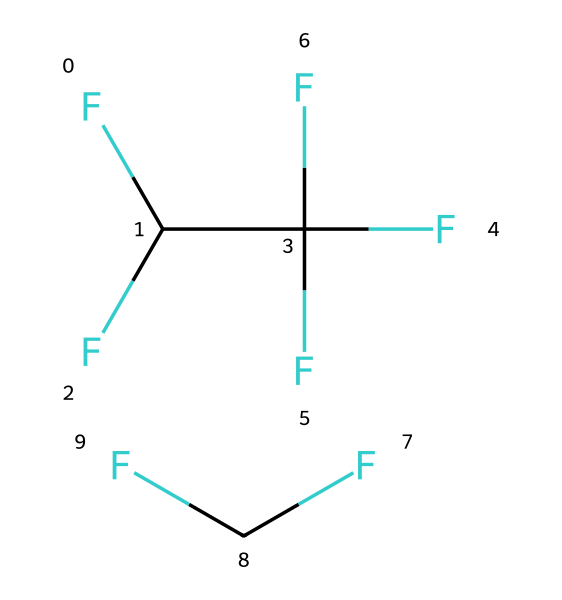How many carbon atoms are present in R-410A? By inspecting the provided SMILES representation, we can count the number of carbon (C) atoms directly. In the first part "FC(F)C(F)(F)F" there are 2 carbon atoms, and in the second part "FC(F)" there is 1 carbon atom. Therefore, adding these together gives us a total of 3 carbon atoms.
Answer: 3 What is the molecular formula of R-410A? To derive the molecular formula from the SMILES representation, we can identify the elements present. In total, there are 3 carbon atoms (C), 8 fluorine atoms (F), and 2 hydrogen atoms (H). The molecular formula combines these counts into C3H2F8.
Answer: C3H2F8 What type of chemical structure does R-410A represent? Based on its composition, R-410A is a zeotropic blend of two types of refrigerants: difluoromethane and pentafluoroethane. This indicates it has a specific structure suited for its function as a refrigerant in HVAC systems.
Answer: zeotropic blend How many fluorine atoms are in the entire R-410A molecule? By analyzing the SMILES representation, we can count the fluorine atoms. In the first portion "FC(F)(F)F" there are 4 fluorine atoms, and in the second part "FC(F)" there are 2 fluorine atoms. Thus, the total is 4 + 2 = 6 fluorine atoms.
Answer: 6 What are the primary functional groups present in R-410A? In the structure of R-410A, we see that it contains multiple fluorine atoms attached to carbon, representing a halogenated hydrocarbon. This specific arrangement points toward the functional groups associated with refrigerants, specifically halocarbons.
Answer: halocarbons Is R-410A a single compound or a mixture? The SMILES notation shows two distinct sections, which indicates R-410A is not a single compound, but a notable blend of two refrigerant compounds, indicating its mixed nature.
Answer: mixture 